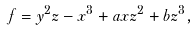Convert formula to latex. <formula><loc_0><loc_0><loc_500><loc_500>f = y ^ { 2 } z - x ^ { 3 } + a x z ^ { 2 } + b z ^ { 3 } ,</formula> 